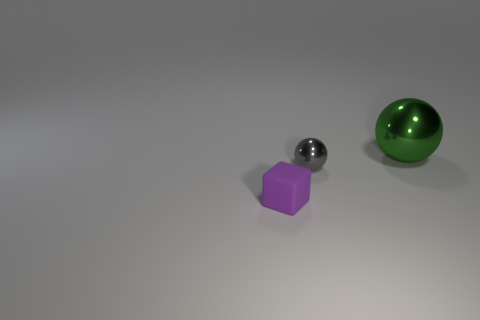What number of other objects are the same shape as the tiny rubber object?
Your answer should be very brief. 0. What shape is the green object that is made of the same material as the gray object?
Your response must be concise. Sphere. Are there any small purple things?
Offer a very short reply. Yes. Are there fewer gray metallic things that are left of the tiny rubber thing than tiny objects that are on the right side of the big green sphere?
Make the answer very short. No. What shape is the small object to the right of the small purple matte thing?
Keep it short and to the point. Sphere. Are the big object and the small gray object made of the same material?
Provide a succinct answer. Yes. Is there any other thing that is made of the same material as the purple object?
Your response must be concise. No. What is the material of the other object that is the same shape as the gray thing?
Keep it short and to the point. Metal. Are there fewer large green shiny objects to the left of the rubber thing than tiny purple rubber cubes?
Your answer should be compact. Yes. There is a tiny matte cube; how many cubes are in front of it?
Your answer should be very brief. 0. 